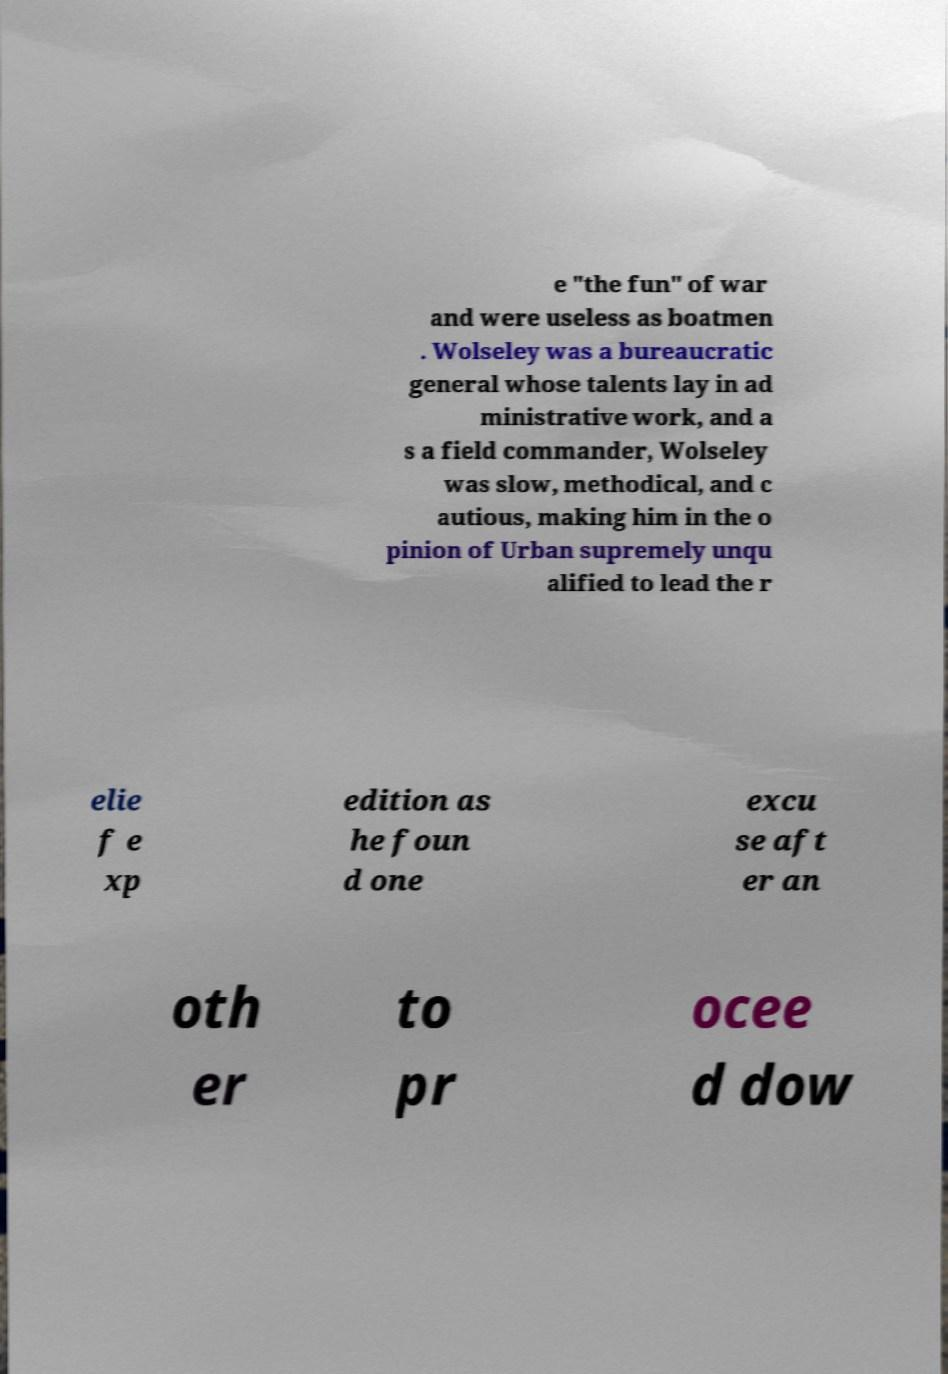Can you accurately transcribe the text from the provided image for me? e "the fun" of war and were useless as boatmen . Wolseley was a bureaucratic general whose talents lay in ad ministrative work, and a s a field commander, Wolseley was slow, methodical, and c autious, making him in the o pinion of Urban supremely unqu alified to lead the r elie f e xp edition as he foun d one excu se aft er an oth er to pr ocee d dow 